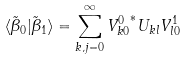Convert formula to latex. <formula><loc_0><loc_0><loc_500><loc_500>\langle \tilde { \beta } _ { 0 } | \tilde { \beta } _ { 1 } \rangle = \sum _ { k , j = 0 } ^ { \infty } { V ^ { 0 } _ { k 0 } } ^ { * } U _ { k l } V _ { l 0 } ^ { 1 }</formula> 